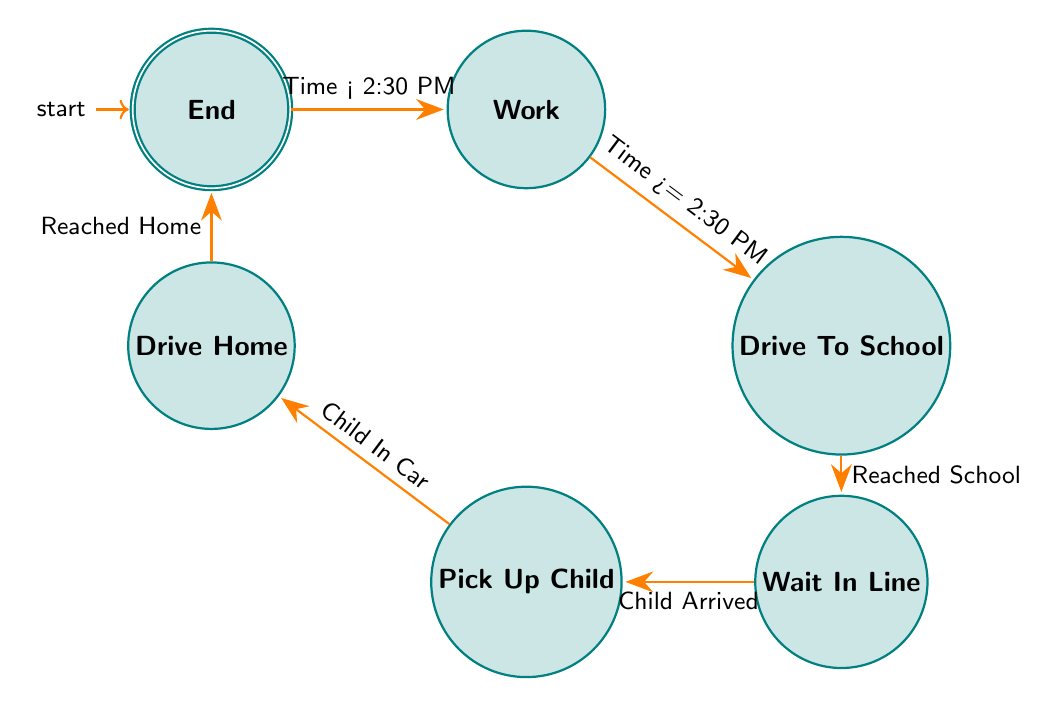What is the starting state in the diagram? The starting state in the diagram is labeled as "Start". It is the first node in the sequence, indicating where the routine begins.
Answer: Start How many nodes are in the finite state machine? To determine the total number of nodes, we can count each distinct state listed in the data: Start, Work, Drive To School, Wait In Line, Pick Up Child, Drive Home, and End, which totals to seven nodes.
Answer: 7 What condition leads from "Work" to "Drive To School"? The condition that leads from "Work" to "Drive To School" is specified as "Time >= 2:30 PM". This means that when the time reaches or exceeds 2:30 PM, the transition occurs.
Answer: Time >= 2:30 PM Which state progresses after "Wait In Line"? The state that progresses after "Wait In Line" is "Pick Up Child". This transition happens when the condition "Child Arrived" is satisfied, allowing the routine to move forward to picking up the child.
Answer: Pick Up Child What is the last state in the routine? The last state in the routine is labeled as "End". It signifies the completion of the school pick-up routine, concluding the series of transitions within the finite state machine.
Answer: End What happens after "Pick Up Child"? After "Pick Up Child", the next state is "Drive Home". The transition occurs when the condition "Child In Car" is met, indicating that the child has been successfully picked up and is now in the car.
Answer: Drive Home Which states have transitions that depend on conditions? The states that have transitions depending on specific conditions are "Work" (condition: Time >= 2:30 PM), "Drive To School" (condition: Reached School), "Wait In Line" (condition: Child Arrived), and "Pick Up Child" (condition: Child In Car). Each of these states requires a certain condition to be met for their respective transitions to occur.
Answer: Work, Drive To School, Wait In Line, Pick Up Child What is the condition for reaching "Wait In Line"? The condition for reaching "Wait In Line" from "Drive To School" is "Reached School". This indicates that once the destination, the school, is reached, the process can continue to waiting in line for the child.
Answer: Reached School 